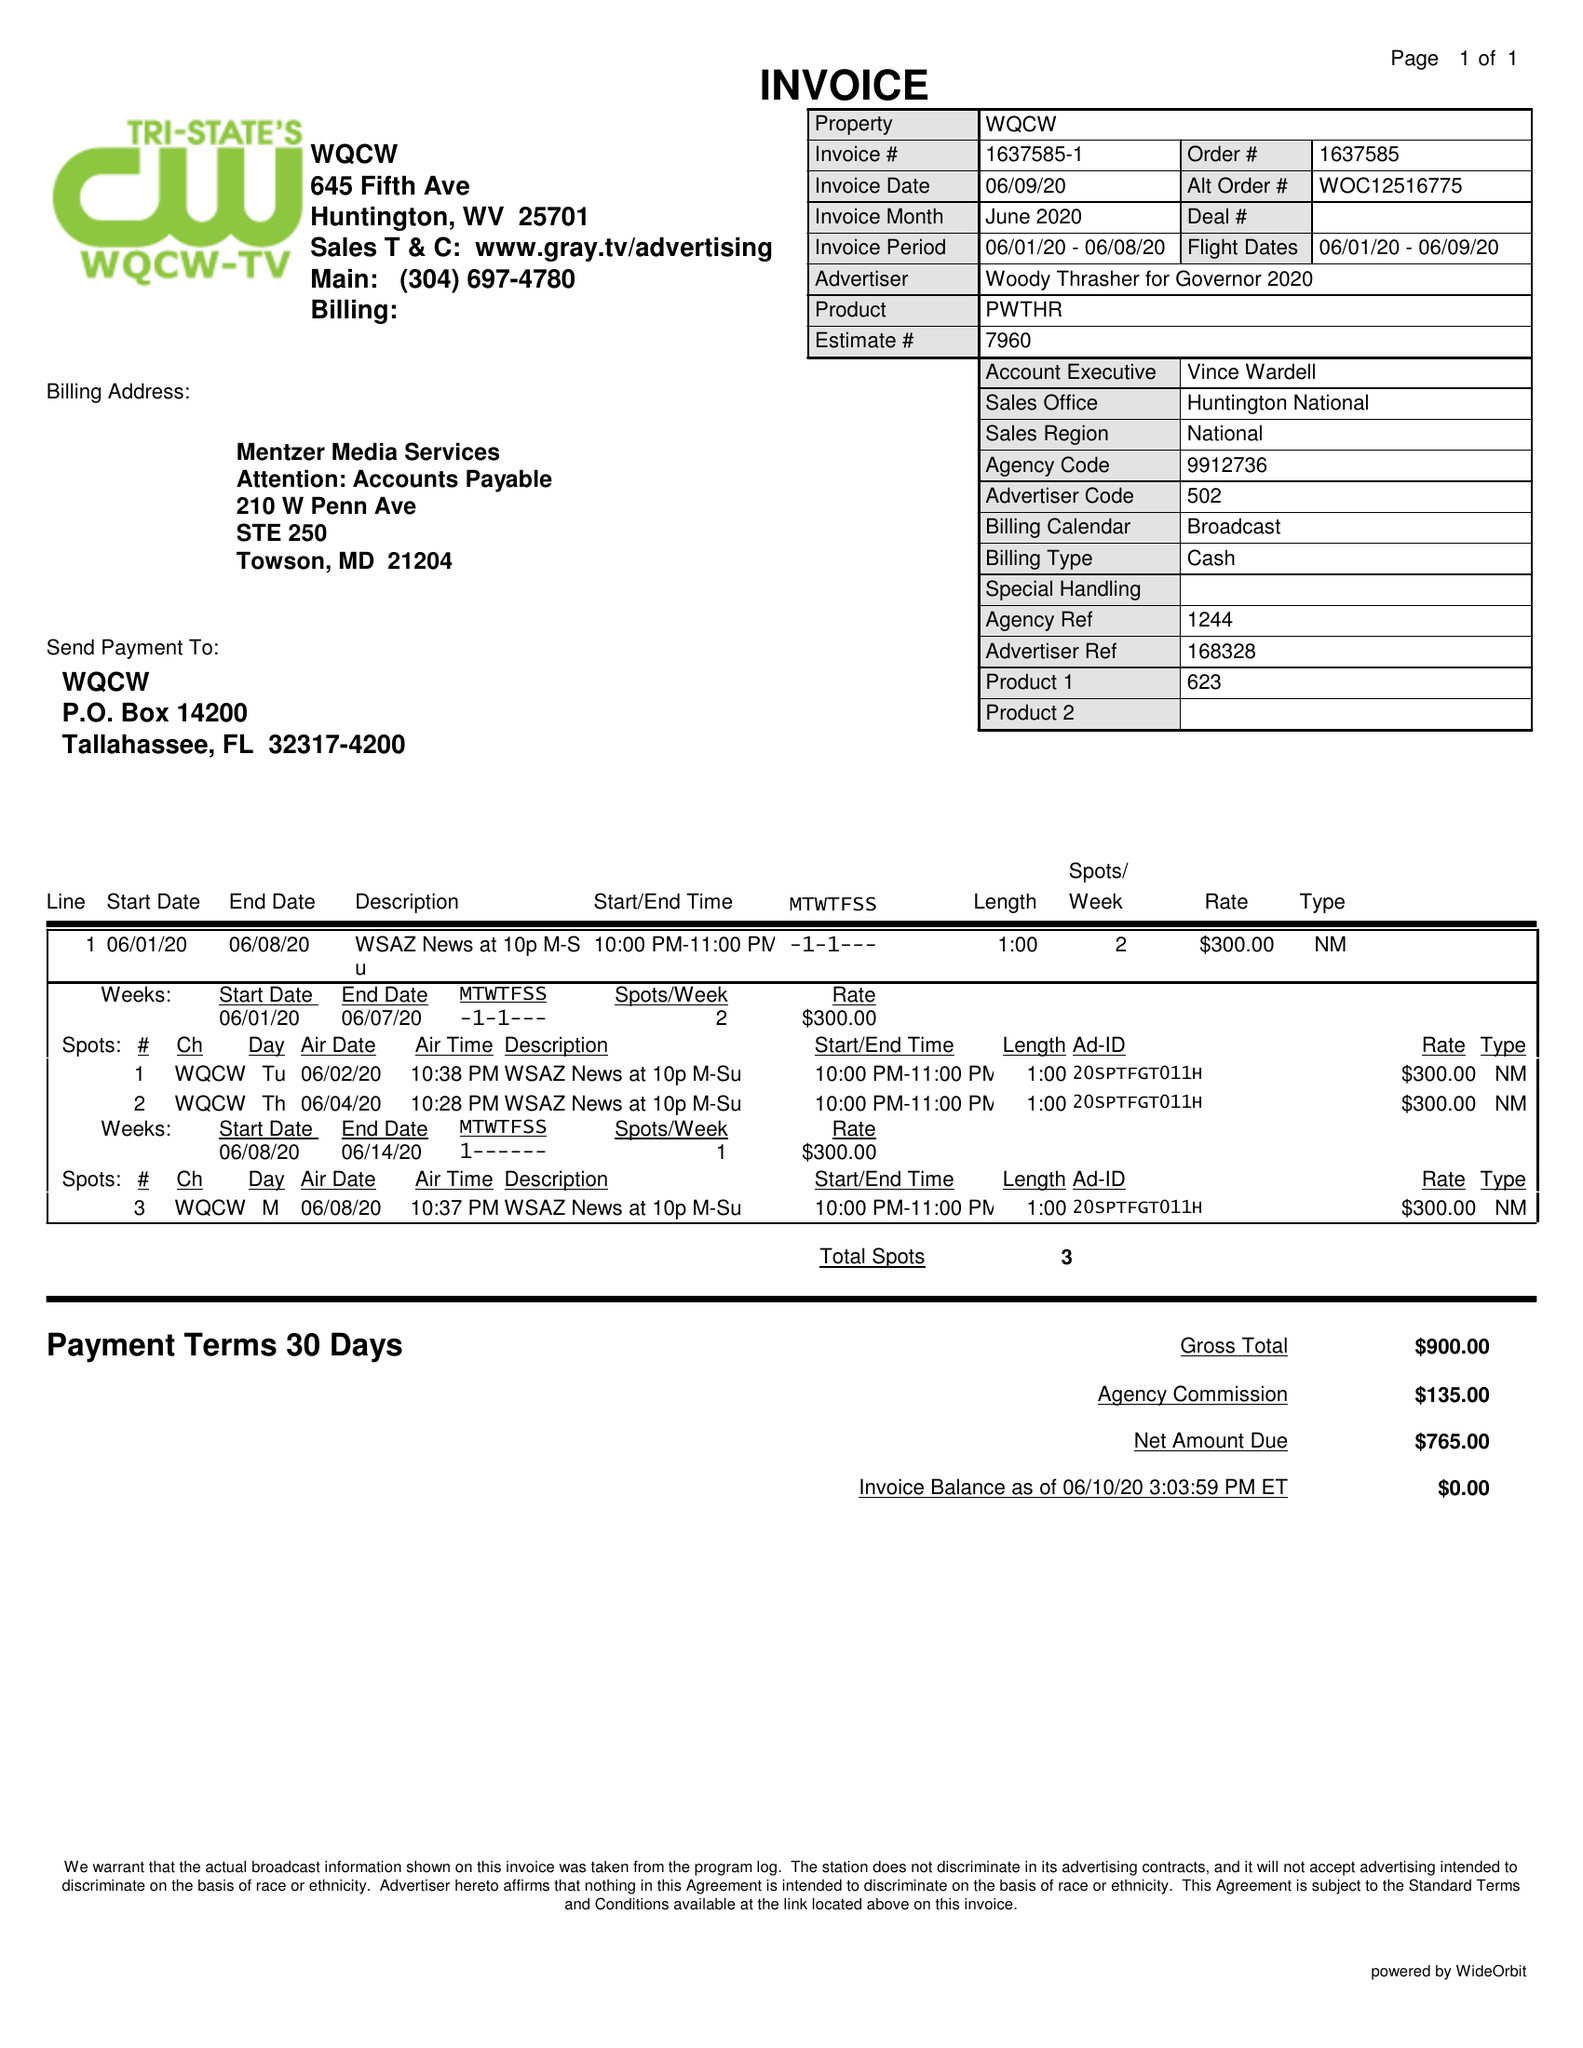What is the value for the flight_to?
Answer the question using a single word or phrase. 06/09/20 